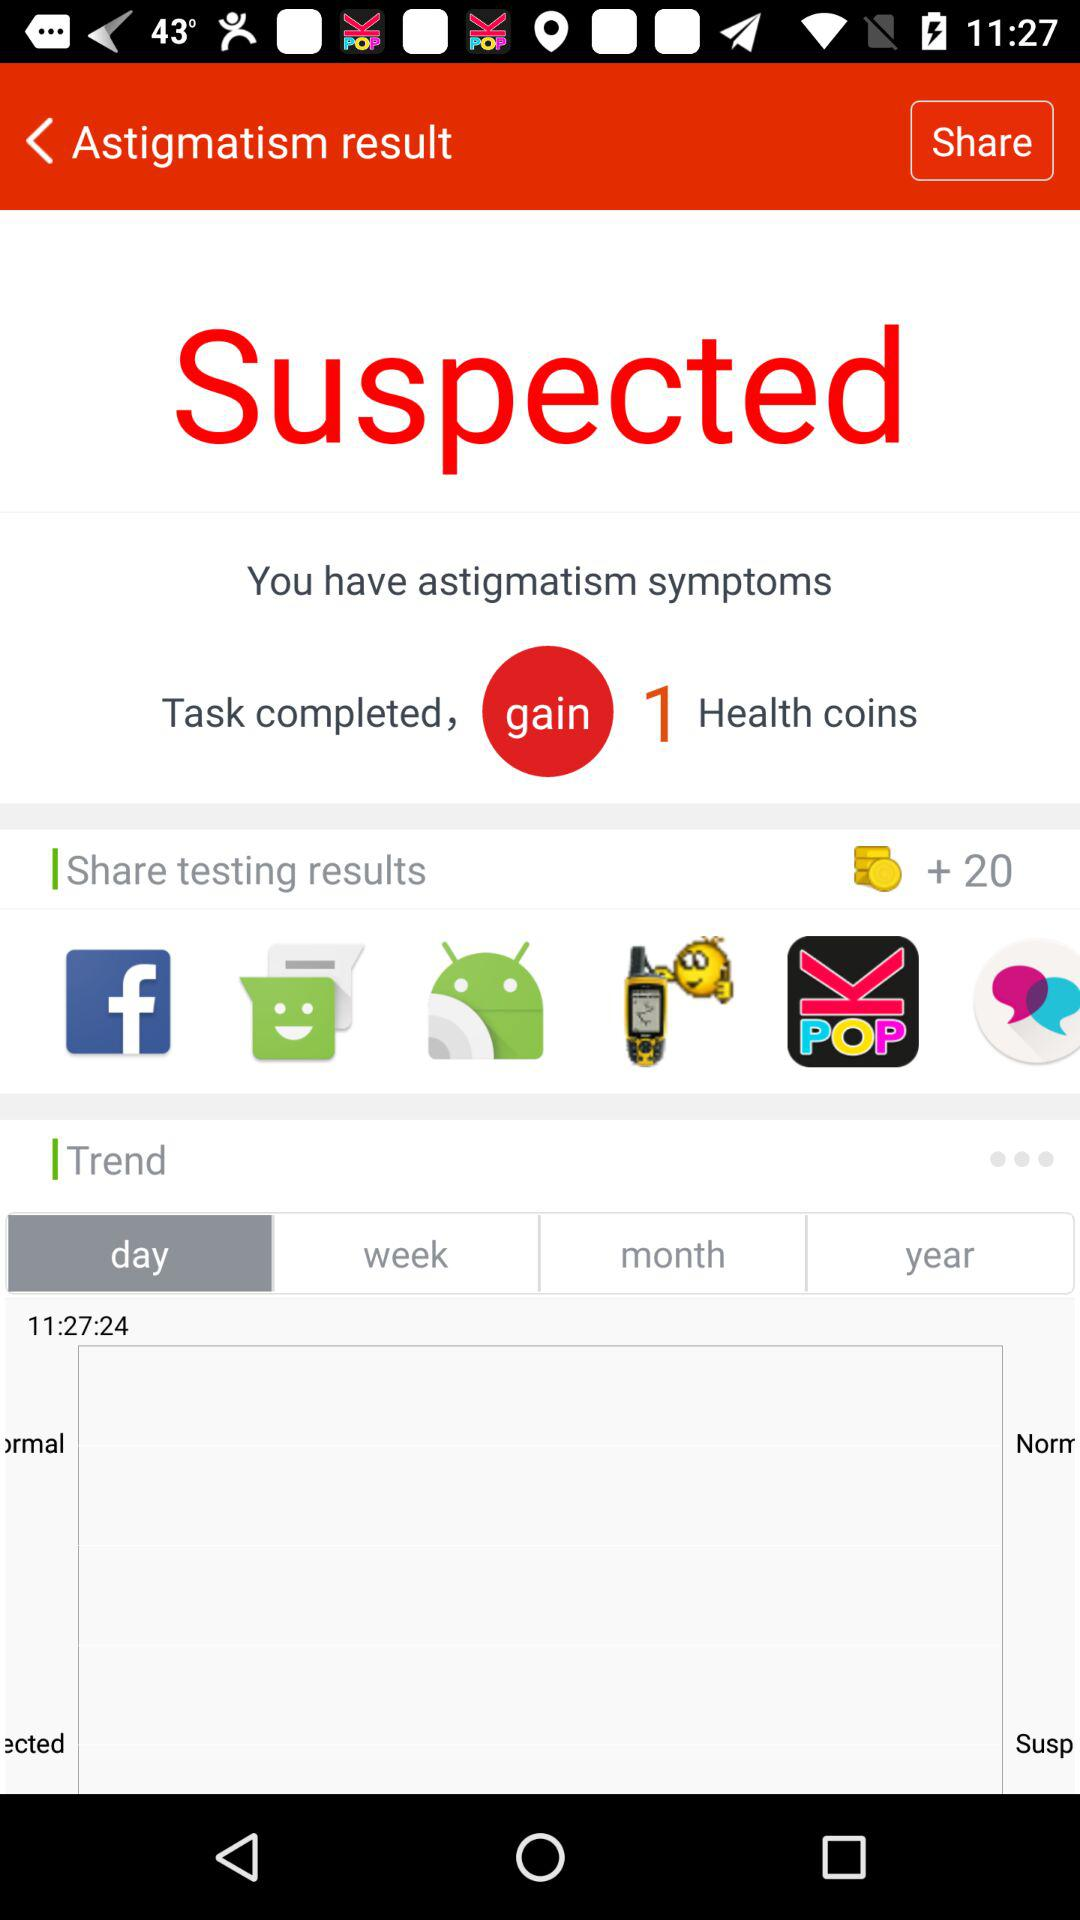Which option has been selected in "Trend"? The option "day" has been selected. 